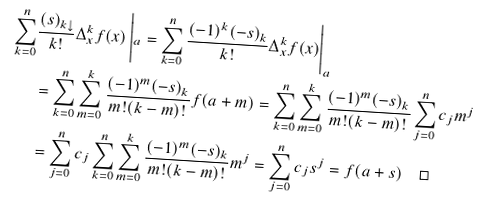<formula> <loc_0><loc_0><loc_500><loc_500>\sum _ { k = 0 } ^ { n } & \frac { ( s ) _ { k \downarrow } } { k ! } \Delta _ { x } ^ { k } f ( x ) \left | _ { a } = \sum _ { k = 0 } ^ { n } \frac { ( - 1 ) ^ { k } ( - s ) _ { k } } { k ! } \Delta _ { x } ^ { k } f ( x ) \right | _ { a } \\ & = \sum _ { k = 0 } ^ { n } \sum _ { m = 0 } ^ { k } \frac { ( - 1 ) ^ { m } ( - s ) _ { k } } { m ! ( k - m ) ! } f ( a + m ) = \sum _ { k = 0 } ^ { n } \sum _ { m = 0 } ^ { k } \frac { ( - 1 ) ^ { m } ( - s ) _ { k } } { m ! ( k - m ) ! } \sum _ { j = 0 } ^ { n } c _ { j } m ^ { j } \\ & = \sum _ { j = 0 } ^ { n } c _ { j } \sum _ { k = 0 } ^ { n } \sum _ { m = 0 } ^ { k } \frac { ( - 1 ) ^ { m } ( - s ) _ { k } } { m ! ( k - m ) ! } m ^ { j } = \sum _ { j = 0 } ^ { n } c _ { j } s ^ { j } = f ( a + s ) \quad \square</formula> 